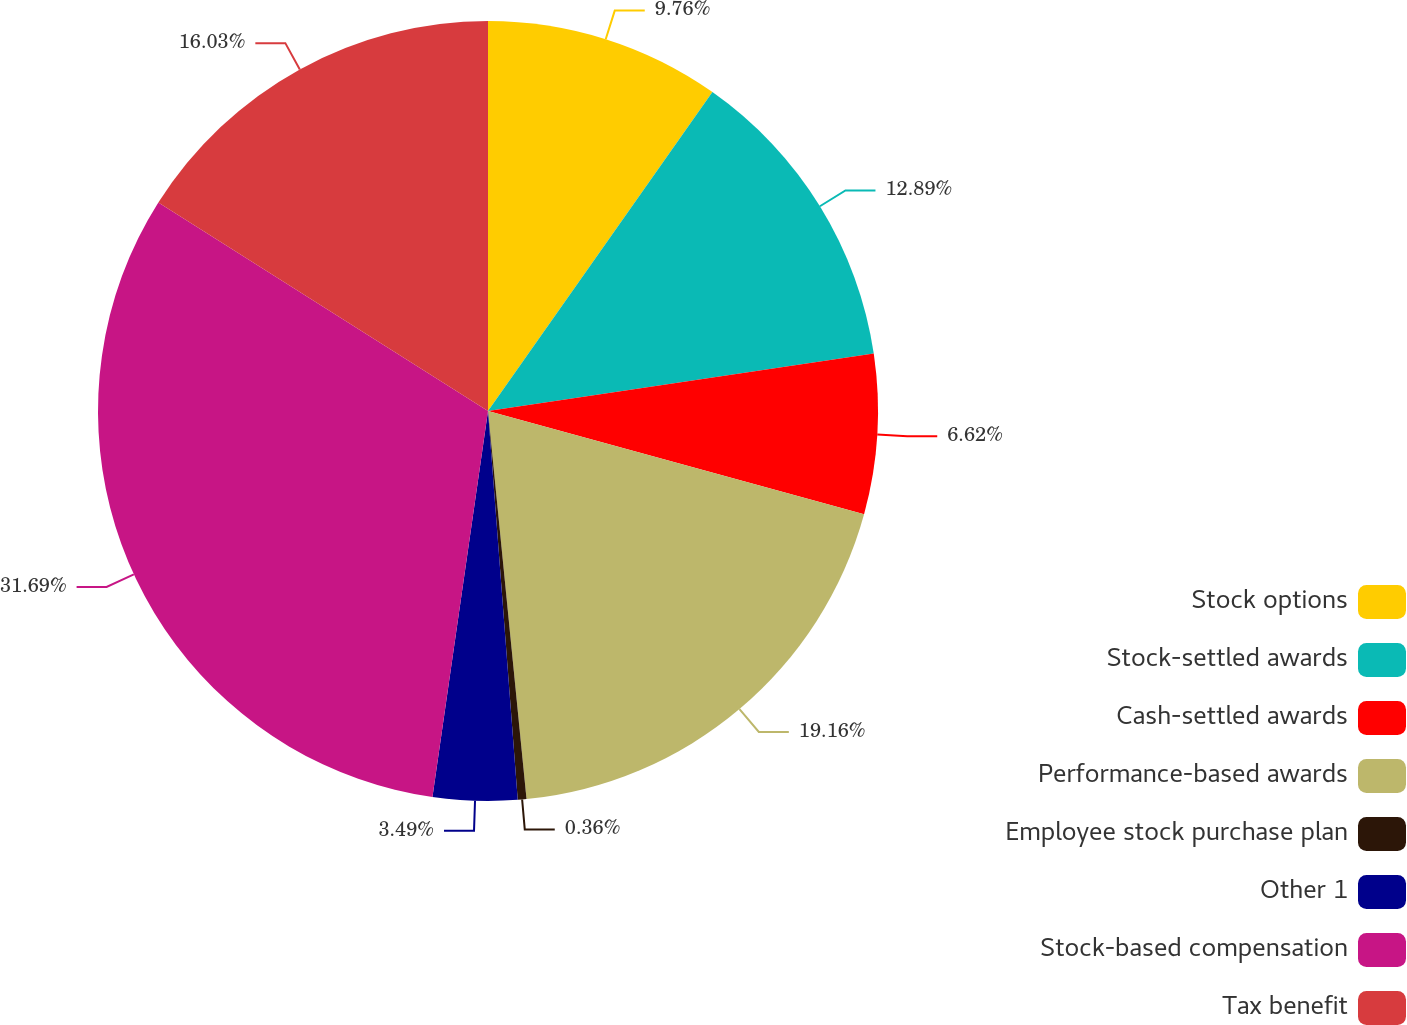<chart> <loc_0><loc_0><loc_500><loc_500><pie_chart><fcel>Stock options<fcel>Stock-settled awards<fcel>Cash-settled awards<fcel>Performance-based awards<fcel>Employee stock purchase plan<fcel>Other 1<fcel>Stock-based compensation<fcel>Tax benefit<nl><fcel>9.76%<fcel>12.89%<fcel>6.62%<fcel>19.16%<fcel>0.36%<fcel>3.49%<fcel>31.7%<fcel>16.03%<nl></chart> 